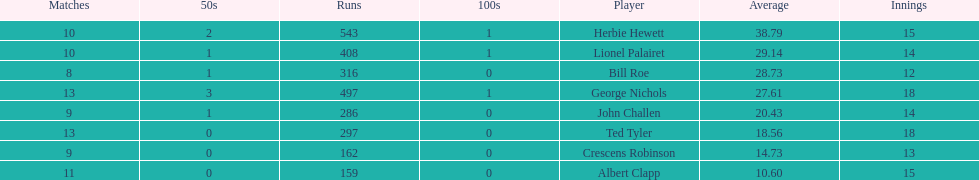How many runs did ted tyler have? 297. 